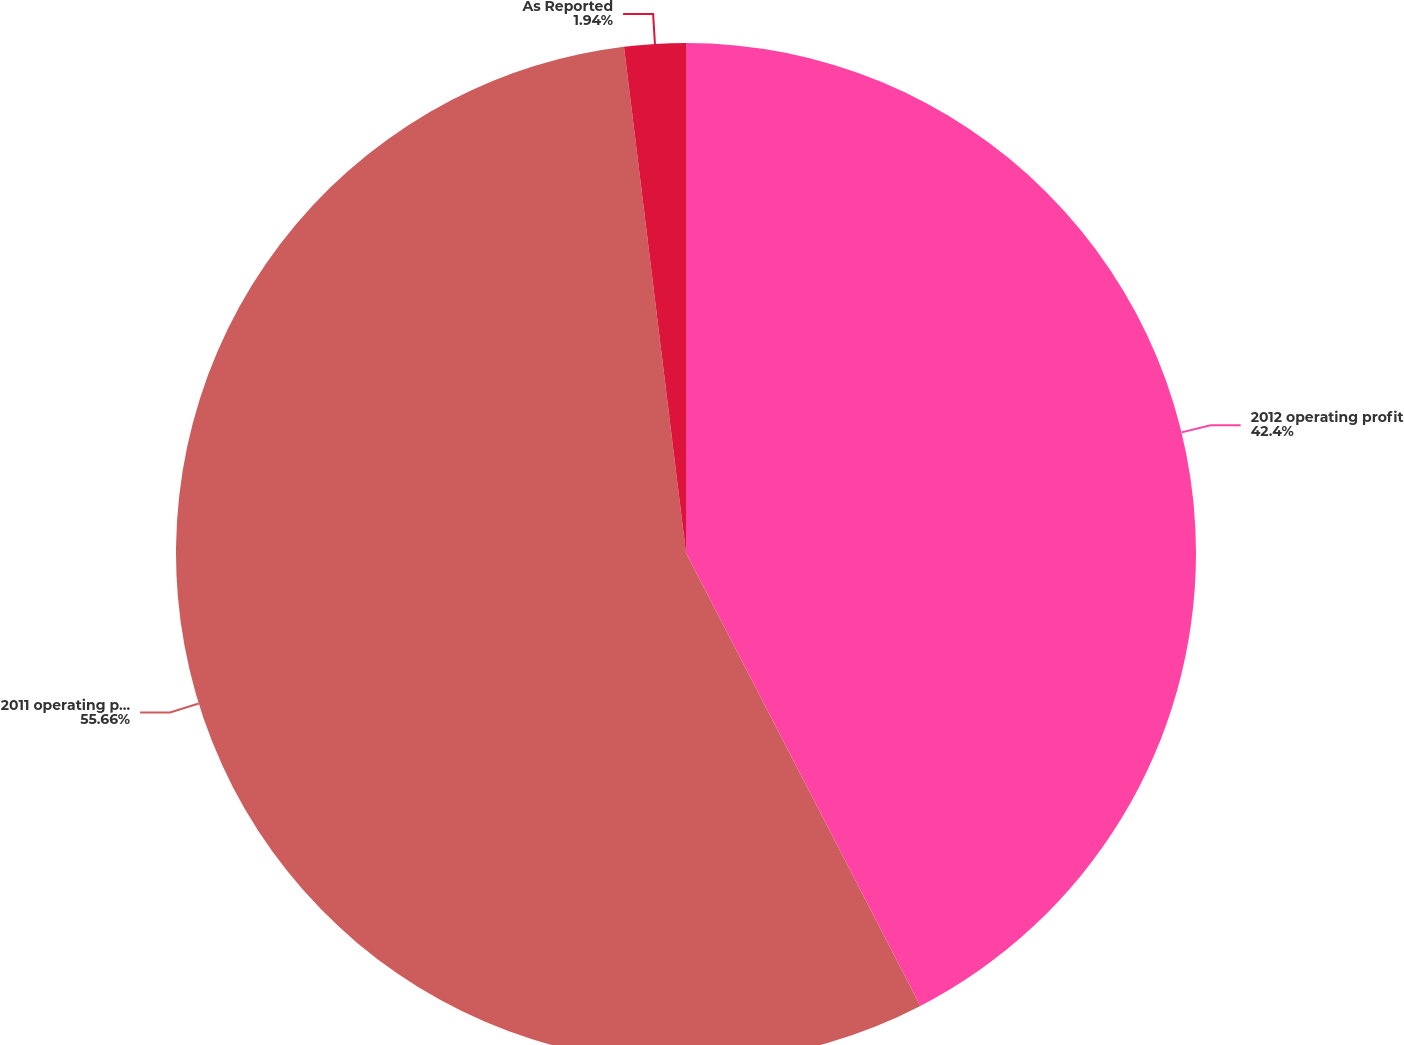Convert chart. <chart><loc_0><loc_0><loc_500><loc_500><pie_chart><fcel>2012 operating profit<fcel>2011 operating profit<fcel>As Reported<nl><fcel>42.4%<fcel>55.66%<fcel>1.94%<nl></chart> 